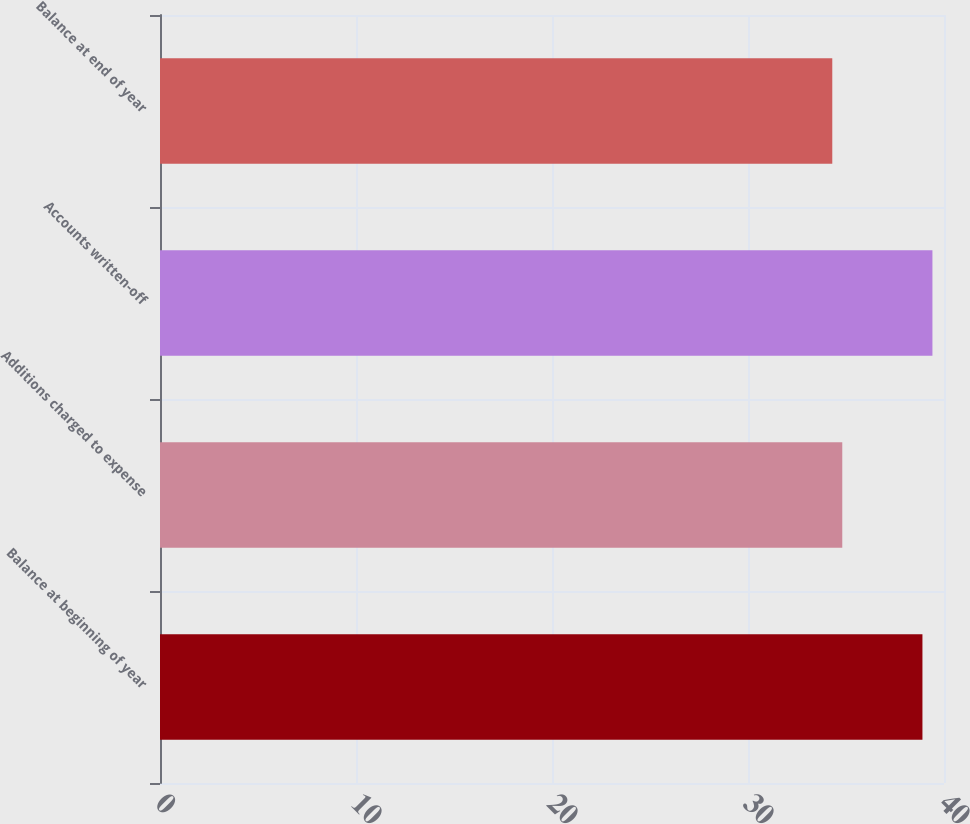Convert chart to OTSL. <chart><loc_0><loc_0><loc_500><loc_500><bar_chart><fcel>Balance at beginning of year<fcel>Additions charged to expense<fcel>Accounts written-off<fcel>Balance at end of year<nl><fcel>38.9<fcel>34.81<fcel>39.41<fcel>34.3<nl></chart> 